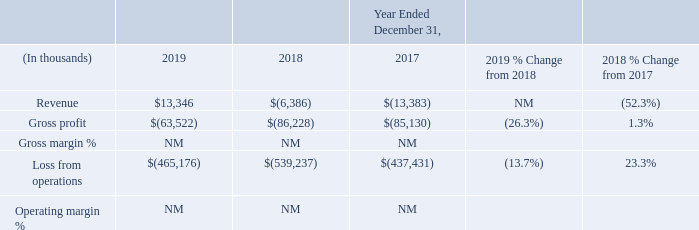Unallocated Amounts
In determining revenue, gross profit and income from operations for our segments, we do not include in revenue the amortization of acquisition related deferred revenue adjustments, which reflect the fair value adjustments to deferred revenues acquired in a business acquisition. We also exclude the amortization of intangible assets, stock-based compensation expense, expenses not reflective of our core business and transaction-related costs and non-cash asset impairment charges from the operating segment data provided to our Chief Operating Decision Maker.
Expenses not reflective of our core business relate to certain severance, product consolidation, legal, consulting and other charges. Accordingly, these amounts are not included in our reportable segment results and are included in the “Unallocated Amounts” category.
The “Unallocated Amounts” category also includes (i) corporate general and administrative expenses (including marketing expenses) and certain research and development expenses related to common solutions and resources that benefit all of our business units, all of which are centrally managed, and (ii) revenue and the associated cost from the resale of certain ancillary products, primarily hardware.
Year Ended December 31, 2019 Compared with the Year Ended December 31, 2018
Revenue from the resale of ancillary products, primarily consisting of hardware, is customer- and project-driven and, as a result, can fluctuate from period to period. The increase in revenue for the year ended December 31, 2019 compared to the prior year was primarily due to only $2 million in amortization of acquisition-related deferred revenue adjustments being recorded during 2019, compared to $24.3 million during 2018.
Gross unallocated expenses, which represent the unallocated loss from operations excluding the impact of revenue, totaled $478 million for the year ended December 31, 2019 compared to $533 million for the year ended December 31, 2018. The decrease was primarily the result of (i) lower asset impairment and goodwill charges of $35 million, (ii) lower net transaction-related severance and legal expenses of $16 million and (iii) lower acquisition related amortization of $1 million. These were partially offset with $3 million in additional stock-based compensation expense.
Year Ended December 31, 2018 Compared with the Year Ended December 31, 2017
Revenue from the resale of ancillary products, primarily consisting of hardware, is customer and project driven and, as a result, can fluctuate from period to period. Revenue for the year ended December 31, 2018 compared with the prior year improved primarily due to lower recognition of amortization of acquisition-related deferred revenue adjustments, which reflect the fair value adjustments to deferred revenues acquired in the EIS Business, Practice Fusion, Health Grid and NantHealth provider/patient engagement acquisitions.
Such adjustments totaled $24 million for the year ended December 31, 2018 compared with $29 million for the year ended December 31, 2017.
Gross unallocated expenses, which represent the unallocated loss from operations excluding the impact of revenue, totaled $533 million for the year ended December 31, 2018 compared with $424 million for the prior year. The increase in the year ended December 31, 2018 compared with prior year was primarily driven by higher transaction-related, severance and legal expenses, primarily related to the acquisitions of the EIS Business, Practice Fusion and Health Grid,
which included higher (i) asset impairment charges of $58 million, (ii) goodwill impairment charges of $14 million, (iii) transaction-related, severance and legal expenses of $30 million, and (iv) amortization of intangible and acquisition-related asset of $9 million. The increase in amortization expense was primarily due to additional amortization expense associated with intangible assets acquired as part of business acquisitions completed since the third quarter of 2017.
What led to increase in revenue for the year ended December 31, 2019 compared to the prior year? Due to only $2 million in amortization of acquisition-related deferred revenue adjustments being recorded during 2019, compared to $24.3 million during 2018. What led to decrease in Gross unallocated expenses for the year ended December 31, 2019 compared to the prior year? Primarily the result of (i) lower asset impairment and goodwill charges of $35 million, (ii) lower net transaction-related severance and legal expenses of $16 million and (iii) lower acquisition related amortization of $1 million. What led to increase in revenue for the year ended December 31, 2018 compared to the prior year? Due to lower recognition of amortization of acquisition-related deferred revenue adjustments, which reflect the fair value adjustments to deferred revenues acquired in the eis business, practice fusion, health grid and nanthealth provider/patient engagement acquisitions. What is the change in Revenue between 2019 and 2017?
Answer scale should be: thousand. 13,346-(13,383)
Answer: 26729. Which year has the highest revenue? 13,346>(6,386)>(13,383)
Answer: 2019. Which years has negative gross profit value? Analyze row 3 values to locate which values are negative
answer: 2019, 2018, 2017. 